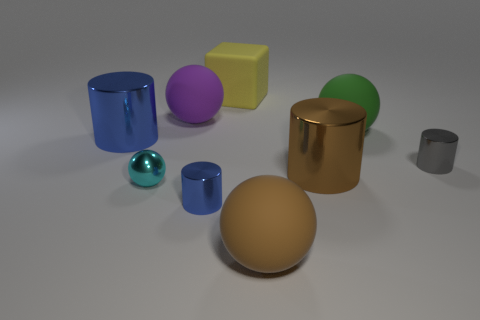What number of yellow objects are either big metal objects or large objects?
Offer a terse response. 1. How many other objects are the same color as the block?
Give a very brief answer. 0. Are there fewer small cylinders to the left of the gray cylinder than large objects?
Ensure brevity in your answer.  Yes. What is the color of the big cylinder behind the tiny thing that is behind the big shiny cylinder that is right of the block?
Give a very brief answer. Blue. There is a cyan metal thing that is the same shape as the big purple matte object; what is its size?
Keep it short and to the point. Small. Are there fewer big blue cylinders that are to the right of the big yellow matte block than blue metallic cylinders that are in front of the tiny blue object?
Your response must be concise. No. There is a rubber object that is in front of the purple rubber object and behind the large brown sphere; what shape is it?
Give a very brief answer. Sphere. The brown thing that is made of the same material as the big purple sphere is what size?
Your answer should be very brief. Large. What material is the sphere that is both right of the tiny blue metallic object and behind the small blue cylinder?
Your answer should be very brief. Rubber. There is a rubber thing that is in front of the cyan object; is it the same shape as the large matte object that is to the left of the yellow rubber cube?
Give a very brief answer. Yes. 